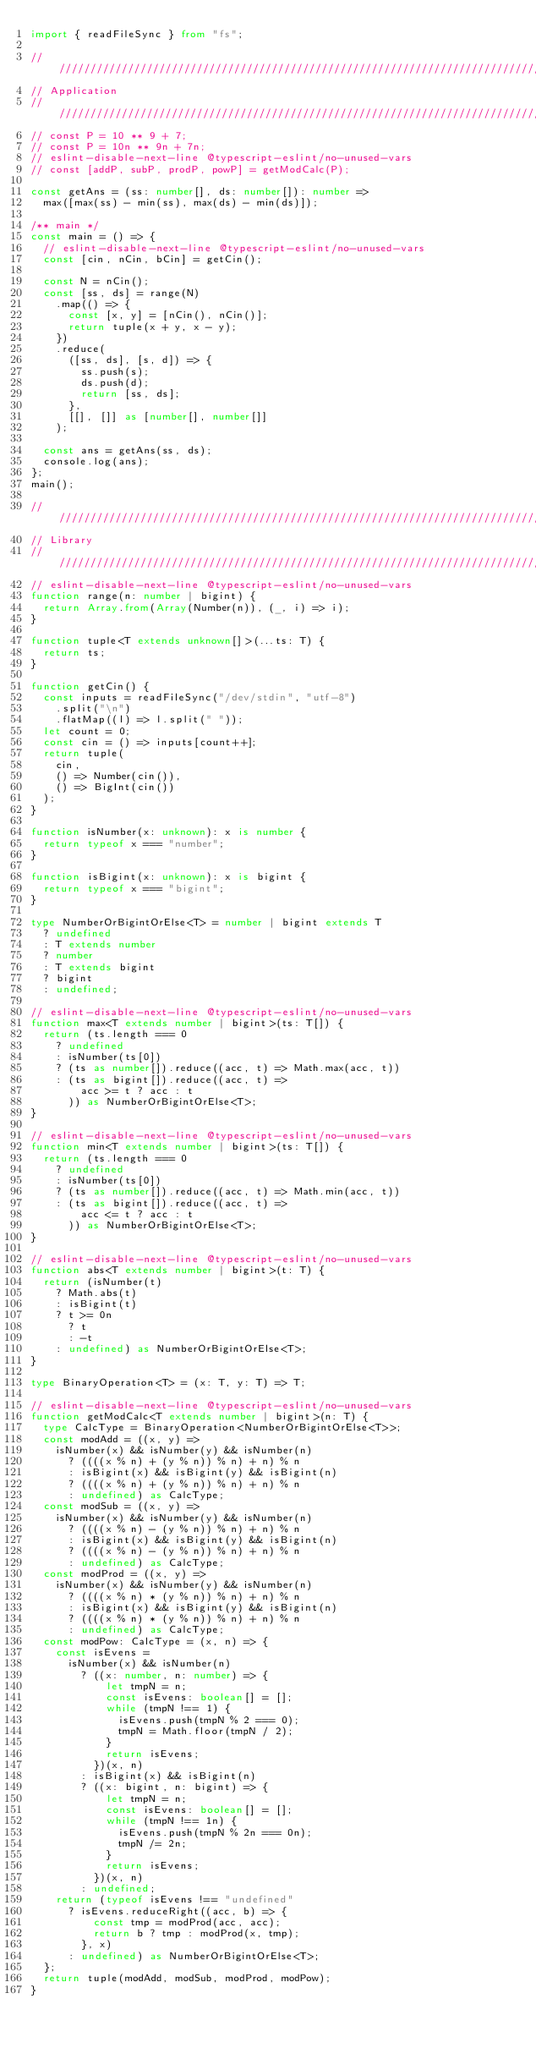<code> <loc_0><loc_0><loc_500><loc_500><_TypeScript_>import { readFileSync } from "fs";

////////////////////////////////////////////////////////////////////////////////
// Application
////////////////////////////////////////////////////////////////////////////////
// const P = 10 ** 9 + 7;
// const P = 10n ** 9n + 7n;
// eslint-disable-next-line @typescript-eslint/no-unused-vars
// const [addP, subP, prodP, powP] = getModCalc(P);

const getAns = (ss: number[], ds: number[]): number =>
  max([max(ss) - min(ss), max(ds) - min(ds)]);

/** main */
const main = () => {
  // eslint-disable-next-line @typescript-eslint/no-unused-vars
  const [cin, nCin, bCin] = getCin();

  const N = nCin();
  const [ss, ds] = range(N)
    .map(() => {
      const [x, y] = [nCin(), nCin()];
      return tuple(x + y, x - y);
    })
    .reduce(
      ([ss, ds], [s, d]) => {
        ss.push(s);
        ds.push(d);
        return [ss, ds];
      },
      [[], []] as [number[], number[]]
    );

  const ans = getAns(ss, ds);
  console.log(ans);
};
main();

////////////////////////////////////////////////////////////////////////////////
// Library
////////////////////////////////////////////////////////////////////////////////
// eslint-disable-next-line @typescript-eslint/no-unused-vars
function range(n: number | bigint) {
  return Array.from(Array(Number(n)), (_, i) => i);
}

function tuple<T extends unknown[]>(...ts: T) {
  return ts;
}

function getCin() {
  const inputs = readFileSync("/dev/stdin", "utf-8")
    .split("\n")
    .flatMap((l) => l.split(" "));
  let count = 0;
  const cin = () => inputs[count++];
  return tuple(
    cin,
    () => Number(cin()),
    () => BigInt(cin())
  );
}

function isNumber(x: unknown): x is number {
  return typeof x === "number";
}

function isBigint(x: unknown): x is bigint {
  return typeof x === "bigint";
}

type NumberOrBigintOrElse<T> = number | bigint extends T
  ? undefined
  : T extends number
  ? number
  : T extends bigint
  ? bigint
  : undefined;

// eslint-disable-next-line @typescript-eslint/no-unused-vars
function max<T extends number | bigint>(ts: T[]) {
  return (ts.length === 0
    ? undefined
    : isNumber(ts[0])
    ? (ts as number[]).reduce((acc, t) => Math.max(acc, t))
    : (ts as bigint[]).reduce((acc, t) =>
        acc >= t ? acc : t
      )) as NumberOrBigintOrElse<T>;
}

// eslint-disable-next-line @typescript-eslint/no-unused-vars
function min<T extends number | bigint>(ts: T[]) {
  return (ts.length === 0
    ? undefined
    : isNumber(ts[0])
    ? (ts as number[]).reduce((acc, t) => Math.min(acc, t))
    : (ts as bigint[]).reduce((acc, t) =>
        acc <= t ? acc : t
      )) as NumberOrBigintOrElse<T>;
}

// eslint-disable-next-line @typescript-eslint/no-unused-vars
function abs<T extends number | bigint>(t: T) {
  return (isNumber(t)
    ? Math.abs(t)
    : isBigint(t)
    ? t >= 0n
      ? t
      : -t
    : undefined) as NumberOrBigintOrElse<T>;
}

type BinaryOperation<T> = (x: T, y: T) => T;

// eslint-disable-next-line @typescript-eslint/no-unused-vars
function getModCalc<T extends number | bigint>(n: T) {
  type CalcType = BinaryOperation<NumberOrBigintOrElse<T>>;
  const modAdd = ((x, y) =>
    isNumber(x) && isNumber(y) && isNumber(n)
      ? ((((x % n) + (y % n)) % n) + n) % n
      : isBigint(x) && isBigint(y) && isBigint(n)
      ? ((((x % n) + (y % n)) % n) + n) % n
      : undefined) as CalcType;
  const modSub = ((x, y) =>
    isNumber(x) && isNumber(y) && isNumber(n)
      ? ((((x % n) - (y % n)) % n) + n) % n
      : isBigint(x) && isBigint(y) && isBigint(n)
      ? ((((x % n) - (y % n)) % n) + n) % n
      : undefined) as CalcType;
  const modProd = ((x, y) =>
    isNumber(x) && isNumber(y) && isNumber(n)
      ? ((((x % n) * (y % n)) % n) + n) % n
      : isBigint(x) && isBigint(y) && isBigint(n)
      ? ((((x % n) * (y % n)) % n) + n) % n
      : undefined) as CalcType;
  const modPow: CalcType = (x, n) => {
    const isEvens =
      isNumber(x) && isNumber(n)
        ? ((x: number, n: number) => {
            let tmpN = n;
            const isEvens: boolean[] = [];
            while (tmpN !== 1) {
              isEvens.push(tmpN % 2 === 0);
              tmpN = Math.floor(tmpN / 2);
            }
            return isEvens;
          })(x, n)
        : isBigint(x) && isBigint(n)
        ? ((x: bigint, n: bigint) => {
            let tmpN = n;
            const isEvens: boolean[] = [];
            while (tmpN !== 1n) {
              isEvens.push(tmpN % 2n === 0n);
              tmpN /= 2n;
            }
            return isEvens;
          })(x, n)
        : undefined;
    return (typeof isEvens !== "undefined"
      ? isEvens.reduceRight((acc, b) => {
          const tmp = modProd(acc, acc);
          return b ? tmp : modProd(x, tmp);
        }, x)
      : undefined) as NumberOrBigintOrElse<T>;
  };
  return tuple(modAdd, modSub, modProd, modPow);
}
</code> 